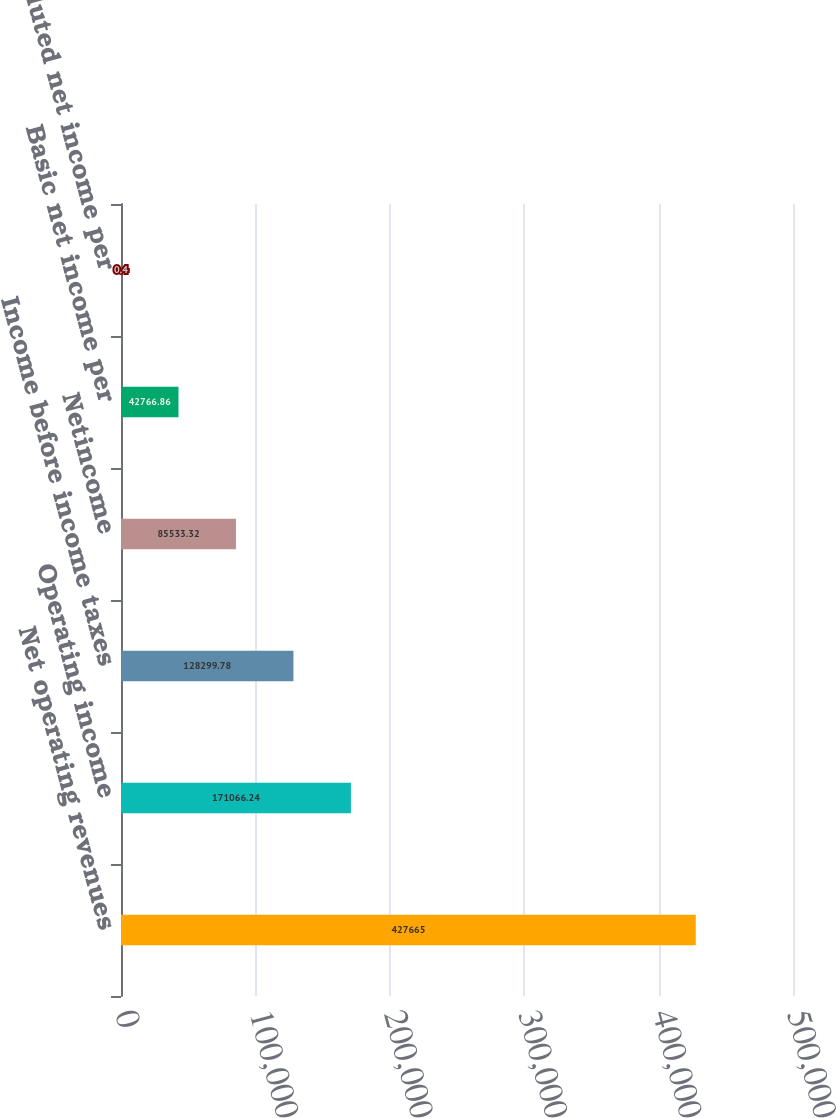Convert chart. <chart><loc_0><loc_0><loc_500><loc_500><bar_chart><fcel>Net operating revenues<fcel>Operating income<fcel>Income before income taxes<fcel>Netincome<fcel>Basic net income per<fcel>Diluted net income per<nl><fcel>427665<fcel>171066<fcel>128300<fcel>85533.3<fcel>42766.9<fcel>0.4<nl></chart> 